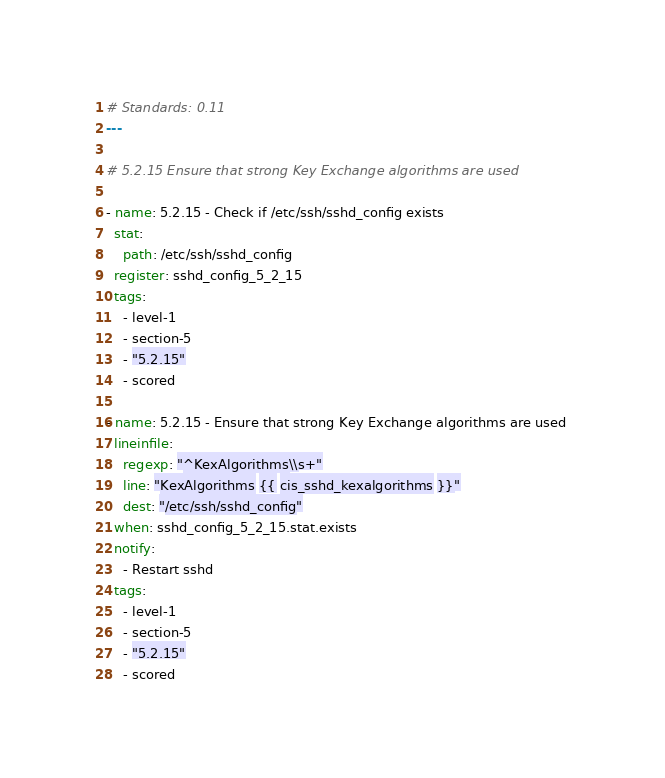<code> <loc_0><loc_0><loc_500><loc_500><_YAML_># Standards: 0.11
---

# 5.2.15 Ensure that strong Key Exchange algorithms are used 

- name: 5.2.15 - Check if /etc/ssh/sshd_config exists
  stat:
    path: /etc/ssh/sshd_config
  register: sshd_config_5_2_15
  tags:
    - level-1
    - section-5
    - "5.2.15"
    - scored

- name: 5.2.15 - Ensure that strong Key Exchange algorithms are used 
  lineinfile:
    regexp: "^KexAlgorithms\\s+"
    line: "KexAlgorithms {{ cis_sshd_kexalgorithms }}"
    dest: "/etc/ssh/sshd_config"
  when: sshd_config_5_2_15.stat.exists
  notify:
    - Restart sshd
  tags:
    - level-1
    - section-5
    - "5.2.15"
    - scored</code> 